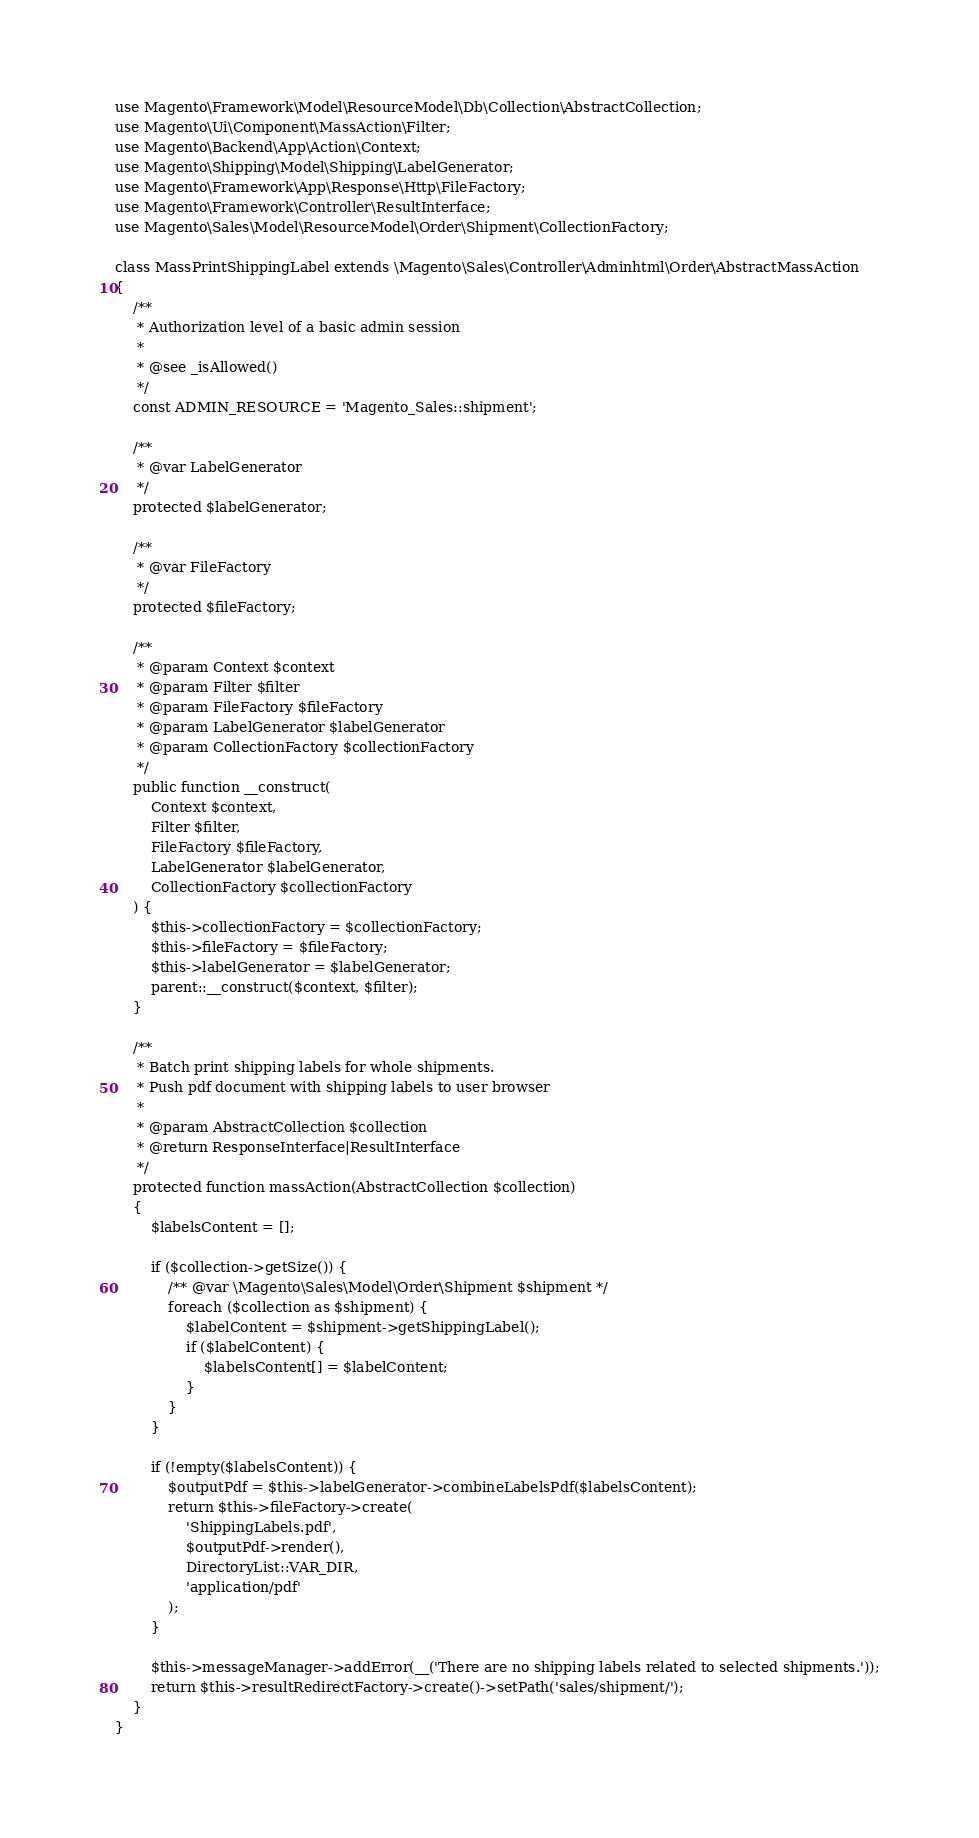<code> <loc_0><loc_0><loc_500><loc_500><_PHP_>use Magento\Framework\Model\ResourceModel\Db\Collection\AbstractCollection;
use Magento\Ui\Component\MassAction\Filter;
use Magento\Backend\App\Action\Context;
use Magento\Shipping\Model\Shipping\LabelGenerator;
use Magento\Framework\App\Response\Http\FileFactory;
use Magento\Framework\Controller\ResultInterface;
use Magento\Sales\Model\ResourceModel\Order\Shipment\CollectionFactory;

class MassPrintShippingLabel extends \Magento\Sales\Controller\Adminhtml\Order\AbstractMassAction
{
    /**
     * Authorization level of a basic admin session
     *
     * @see _isAllowed()
     */
    const ADMIN_RESOURCE = 'Magento_Sales::shipment';

    /**
     * @var LabelGenerator
     */
    protected $labelGenerator;

    /**
     * @var FileFactory
     */
    protected $fileFactory;

    /**
     * @param Context $context
     * @param Filter $filter
     * @param FileFactory $fileFactory
     * @param LabelGenerator $labelGenerator
     * @param CollectionFactory $collectionFactory
     */
    public function __construct(
        Context $context,
        Filter $filter,
        FileFactory $fileFactory,
        LabelGenerator $labelGenerator,
        CollectionFactory $collectionFactory
    ) {
        $this->collectionFactory = $collectionFactory;
        $this->fileFactory = $fileFactory;
        $this->labelGenerator = $labelGenerator;
        parent::__construct($context, $filter);
    }

    /**
     * Batch print shipping labels for whole shipments.
     * Push pdf document with shipping labels to user browser
     *
     * @param AbstractCollection $collection
     * @return ResponseInterface|ResultInterface
     */
    protected function massAction(AbstractCollection $collection)
    {
        $labelsContent = [];

        if ($collection->getSize()) {
            /** @var \Magento\Sales\Model\Order\Shipment $shipment */
            foreach ($collection as $shipment) {
                $labelContent = $shipment->getShippingLabel();
                if ($labelContent) {
                    $labelsContent[] = $labelContent;
                }
            }
        }

        if (!empty($labelsContent)) {
            $outputPdf = $this->labelGenerator->combineLabelsPdf($labelsContent);
            return $this->fileFactory->create(
                'ShippingLabels.pdf',
                $outputPdf->render(),
                DirectoryList::VAR_DIR,
                'application/pdf'
            );
        }

        $this->messageManager->addError(__('There are no shipping labels related to selected shipments.'));
        return $this->resultRedirectFactory->create()->setPath('sales/shipment/');
    }
}
</code> 